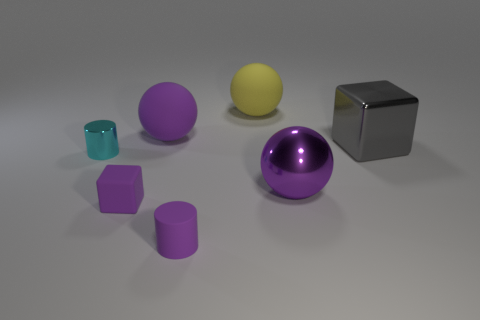Add 1 purple matte objects. How many objects exist? 8 Subtract 1 cubes. How many cubes are left? 1 Subtract all big yellow matte spheres. How many spheres are left? 2 Add 7 purple rubber balls. How many purple rubber balls exist? 8 Subtract all purple cylinders. How many cylinders are left? 1 Subtract 1 purple cylinders. How many objects are left? 6 Subtract all balls. How many objects are left? 4 Subtract all green spheres. Subtract all yellow cylinders. How many spheres are left? 3 Subtract all blue spheres. How many purple blocks are left? 1 Subtract all big yellow objects. Subtract all metal objects. How many objects are left? 3 